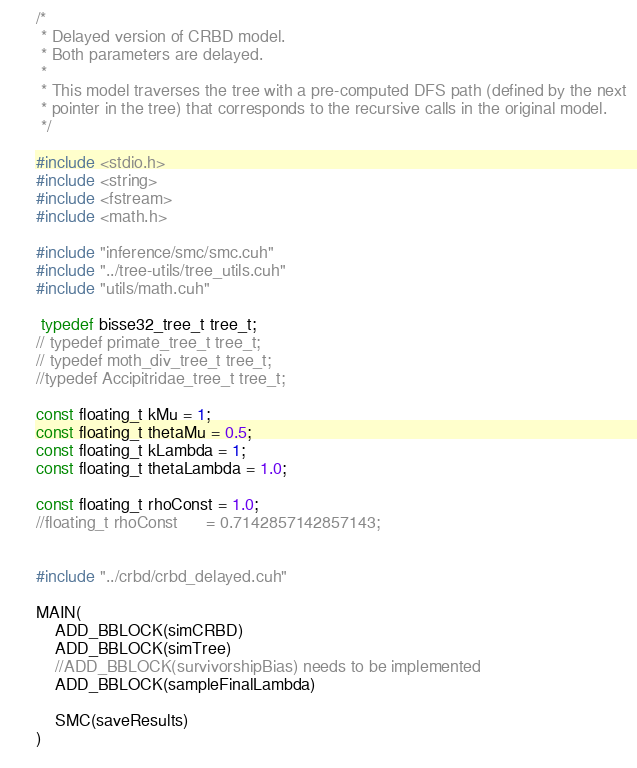Convert code to text. <code><loc_0><loc_0><loc_500><loc_500><_Cuda_>/*
 * Delayed version of CRBD model.
 * Both parameters are delayed.
 *
 * This model traverses the tree with a pre-computed DFS path (defined by the next 
 * pointer in the tree) that corresponds to the recursive calls in the original model. 
 */

#include <stdio.h>
#include <string>
#include <fstream>
#include <math.h>

#include "inference/smc/smc.cuh"
#include "../tree-utils/tree_utils.cuh"
#include "utils/math.cuh"

 typedef bisse32_tree_t tree_t;
// typedef primate_tree_t tree_t;
// typedef moth_div_tree_t tree_t;
//typedef Accipitridae_tree_t tree_t;
 
const floating_t kMu = 1;
const floating_t thetaMu = 0.5;
const floating_t kLambda = 1;
const floating_t thetaLambda = 1.0;

const floating_t rhoConst = 1.0;
//floating_t rhoConst      = 0.7142857142857143;


#include "../crbd/crbd_delayed.cuh"

MAIN(    
    ADD_BBLOCK(simCRBD)
    ADD_BBLOCK(simTree)
    //ADD_BBLOCK(survivorshipBias) needs to be implemented
    ADD_BBLOCK(sampleFinalLambda)
    
    SMC(saveResults)
)
  
</code> 